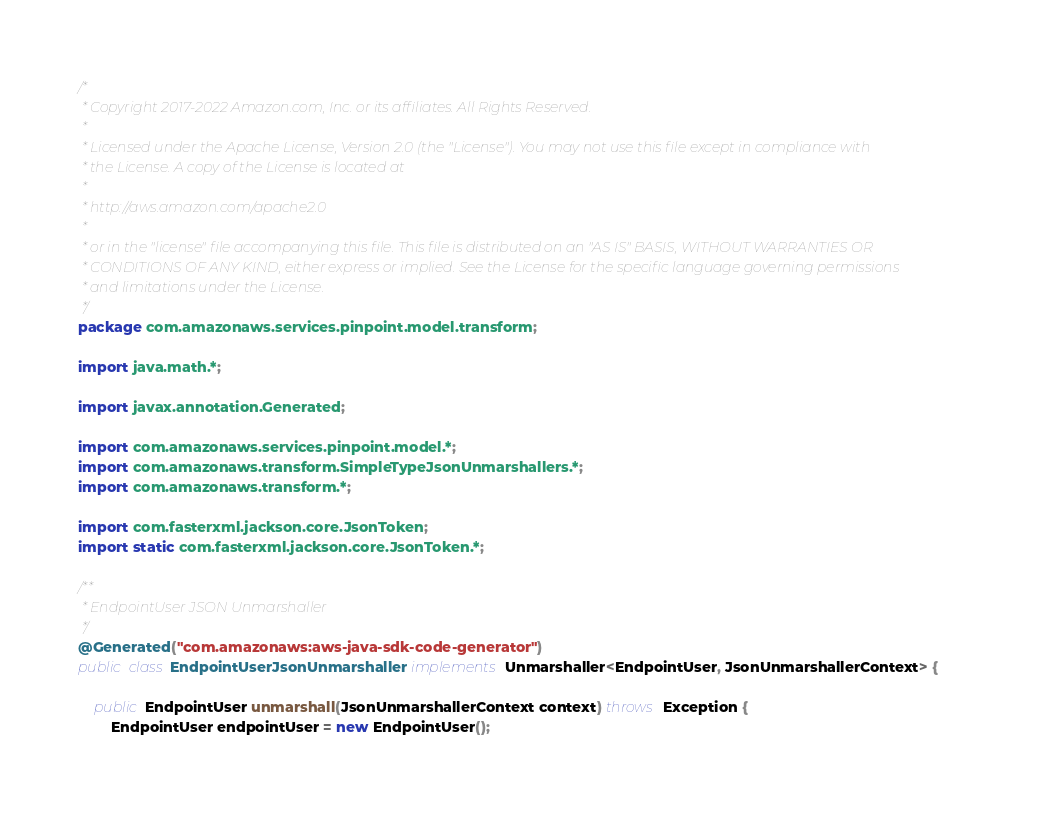Convert code to text. <code><loc_0><loc_0><loc_500><loc_500><_Java_>/*
 * Copyright 2017-2022 Amazon.com, Inc. or its affiliates. All Rights Reserved.
 * 
 * Licensed under the Apache License, Version 2.0 (the "License"). You may not use this file except in compliance with
 * the License. A copy of the License is located at
 * 
 * http://aws.amazon.com/apache2.0
 * 
 * or in the "license" file accompanying this file. This file is distributed on an "AS IS" BASIS, WITHOUT WARRANTIES OR
 * CONDITIONS OF ANY KIND, either express or implied. See the License for the specific language governing permissions
 * and limitations under the License.
 */
package com.amazonaws.services.pinpoint.model.transform;

import java.math.*;

import javax.annotation.Generated;

import com.amazonaws.services.pinpoint.model.*;
import com.amazonaws.transform.SimpleTypeJsonUnmarshallers.*;
import com.amazonaws.transform.*;

import com.fasterxml.jackson.core.JsonToken;
import static com.fasterxml.jackson.core.JsonToken.*;

/**
 * EndpointUser JSON Unmarshaller
 */
@Generated("com.amazonaws:aws-java-sdk-code-generator")
public class EndpointUserJsonUnmarshaller implements Unmarshaller<EndpointUser, JsonUnmarshallerContext> {

    public EndpointUser unmarshall(JsonUnmarshallerContext context) throws Exception {
        EndpointUser endpointUser = new EndpointUser();
</code> 